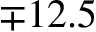Convert formula to latex. <formula><loc_0><loc_0><loc_500><loc_500>\mp 1 2 . 5</formula> 